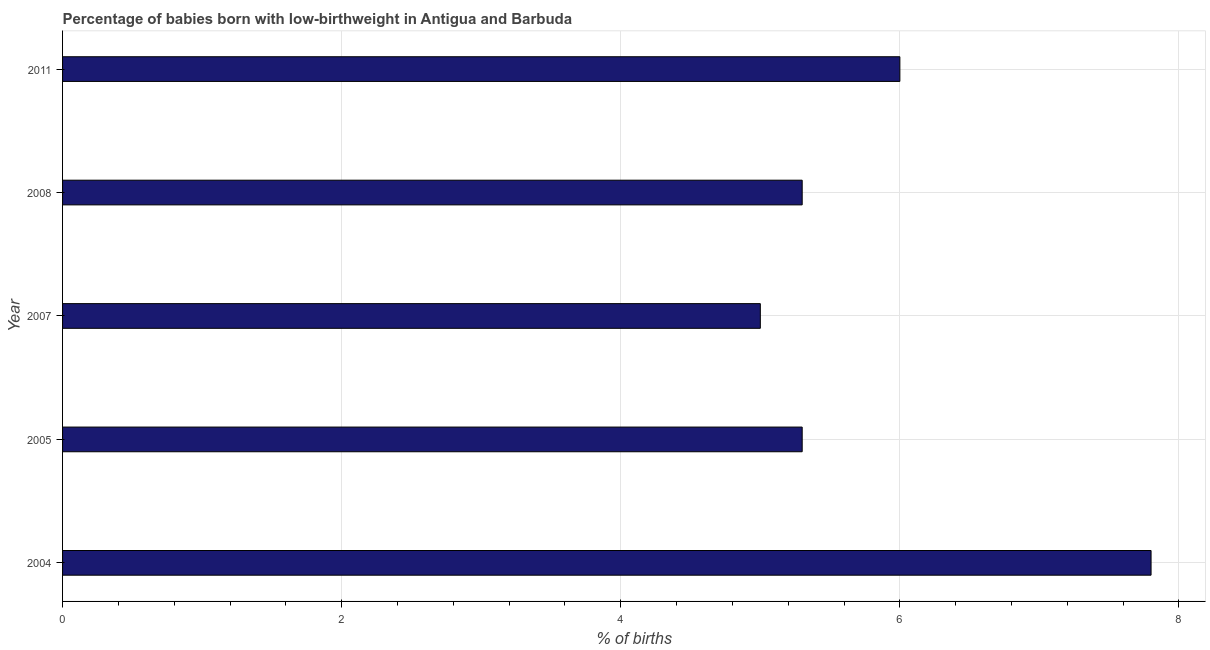Does the graph contain grids?
Offer a very short reply. Yes. What is the title of the graph?
Keep it short and to the point. Percentage of babies born with low-birthweight in Antigua and Barbuda. What is the label or title of the X-axis?
Make the answer very short. % of births. Across all years, what is the maximum percentage of babies who were born with low-birthweight?
Ensure brevity in your answer.  7.8. Across all years, what is the minimum percentage of babies who were born with low-birthweight?
Ensure brevity in your answer.  5. In which year was the percentage of babies who were born with low-birthweight minimum?
Provide a short and direct response. 2007. What is the sum of the percentage of babies who were born with low-birthweight?
Your answer should be compact. 29.4. What is the difference between the percentage of babies who were born with low-birthweight in 2004 and 2007?
Your response must be concise. 2.8. What is the average percentage of babies who were born with low-birthweight per year?
Ensure brevity in your answer.  5.88. What is the median percentage of babies who were born with low-birthweight?
Offer a very short reply. 5.3. What is the ratio of the percentage of babies who were born with low-birthweight in 2005 to that in 2007?
Your response must be concise. 1.06. Is the percentage of babies who were born with low-birthweight in 2007 less than that in 2008?
Offer a terse response. Yes. Is the difference between the percentage of babies who were born with low-birthweight in 2004 and 2011 greater than the difference between any two years?
Offer a very short reply. No. What is the difference between the highest and the second highest percentage of babies who were born with low-birthweight?
Offer a terse response. 1.8. Is the sum of the percentage of babies who were born with low-birthweight in 2004 and 2008 greater than the maximum percentage of babies who were born with low-birthweight across all years?
Ensure brevity in your answer.  Yes. What is the difference between the highest and the lowest percentage of babies who were born with low-birthweight?
Your response must be concise. 2.8. In how many years, is the percentage of babies who were born with low-birthweight greater than the average percentage of babies who were born with low-birthweight taken over all years?
Offer a very short reply. 2. How many bars are there?
Give a very brief answer. 5. What is the difference between two consecutive major ticks on the X-axis?
Provide a short and direct response. 2. What is the % of births in 2004?
Your response must be concise. 7.8. What is the % of births of 2005?
Make the answer very short. 5.3. What is the % of births in 2007?
Provide a short and direct response. 5. What is the difference between the % of births in 2004 and 2005?
Offer a very short reply. 2.5. What is the difference between the % of births in 2005 and 2007?
Offer a very short reply. 0.3. What is the difference between the % of births in 2005 and 2011?
Offer a very short reply. -0.7. What is the difference between the % of births in 2007 and 2011?
Provide a short and direct response. -1. What is the difference between the % of births in 2008 and 2011?
Give a very brief answer. -0.7. What is the ratio of the % of births in 2004 to that in 2005?
Offer a terse response. 1.47. What is the ratio of the % of births in 2004 to that in 2007?
Provide a short and direct response. 1.56. What is the ratio of the % of births in 2004 to that in 2008?
Offer a very short reply. 1.47. What is the ratio of the % of births in 2004 to that in 2011?
Provide a succinct answer. 1.3. What is the ratio of the % of births in 2005 to that in 2007?
Your response must be concise. 1.06. What is the ratio of the % of births in 2005 to that in 2011?
Make the answer very short. 0.88. What is the ratio of the % of births in 2007 to that in 2008?
Provide a short and direct response. 0.94. What is the ratio of the % of births in 2007 to that in 2011?
Offer a very short reply. 0.83. What is the ratio of the % of births in 2008 to that in 2011?
Keep it short and to the point. 0.88. 